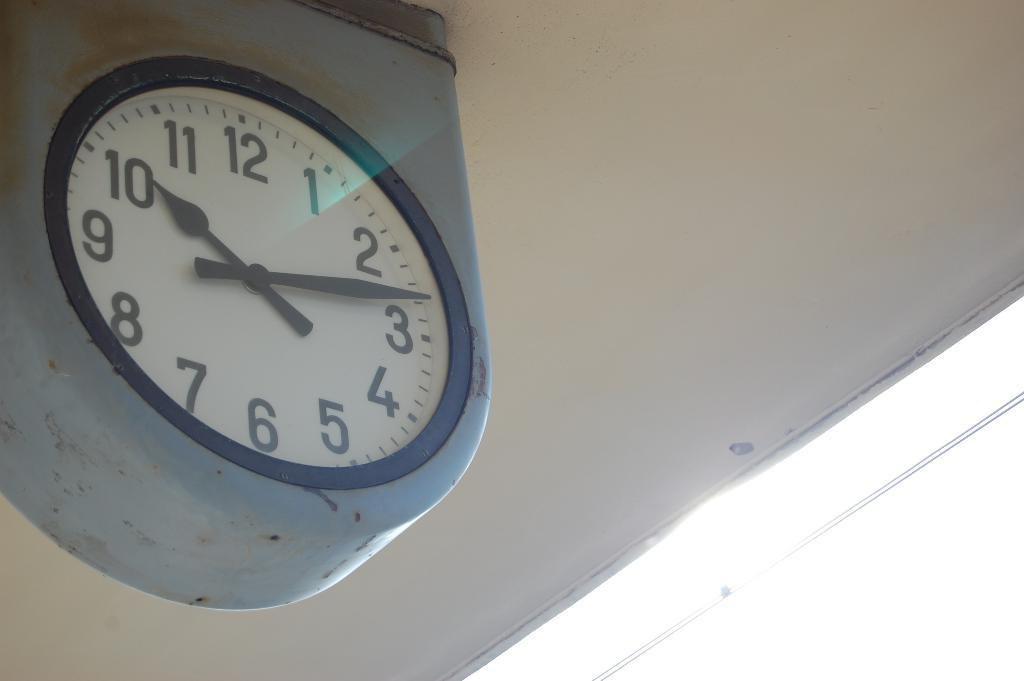Provide a one-sentence caption for the provided image. An analog clock shows the time to be 10:13. 